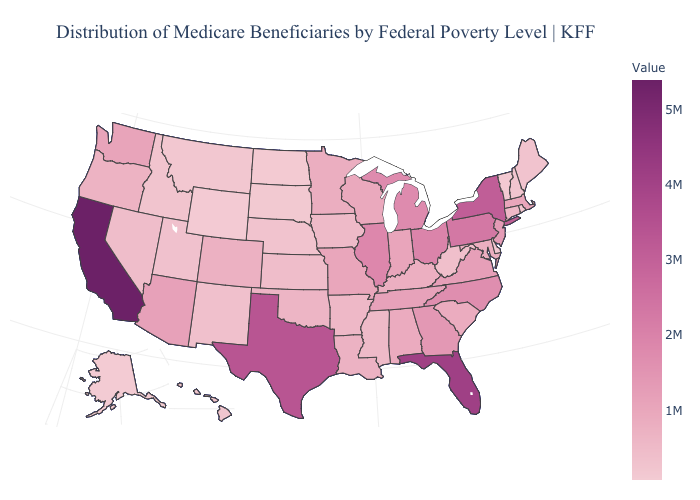Does Missouri have the highest value in the USA?
Answer briefly. No. Which states have the lowest value in the USA?
Give a very brief answer. Alaska. Does Kentucky have the lowest value in the USA?
Keep it brief. No. Which states hav the highest value in the West?
Give a very brief answer. California. Does New York have the highest value in the USA?
Be succinct. No. 